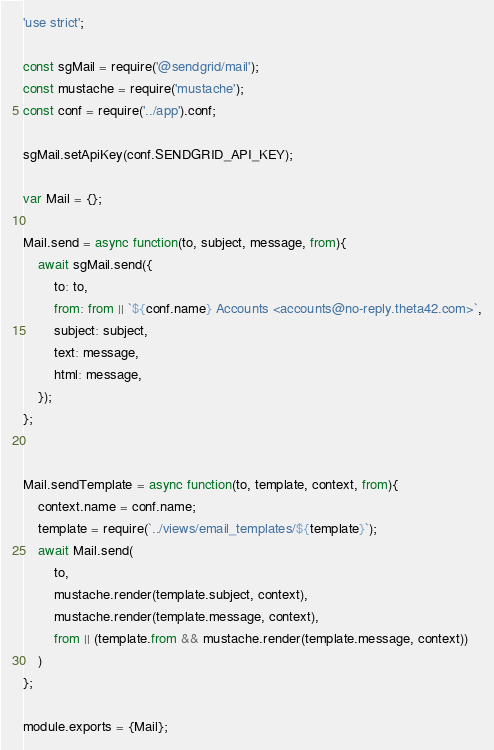Convert code to text. <code><loc_0><loc_0><loc_500><loc_500><_JavaScript_>'use strict';

const sgMail = require('@sendgrid/mail');
const mustache = require('mustache');
const conf = require('../app').conf;

sgMail.setApiKey(conf.SENDGRID_API_KEY);

var Mail = {};

Mail.send = async function(to, subject, message, from){
	await sgMail.send({
		to: to,
		from: from || `${conf.name} Accounts <accounts@no-reply.theta42.com>`,
		subject: subject,
		text: message,
		html: message,
	});
};


Mail.sendTemplate = async function(to, template, context, from){
	context.name = conf.name;
	template = require(`../views/email_templates/${template}`);
	await Mail.send(
		to,
		mustache.render(template.subject, context),
		mustache.render(template.message, context),
		from || (template.from && mustache.render(template.message, context))
	)
};

module.exports = {Mail};
</code> 